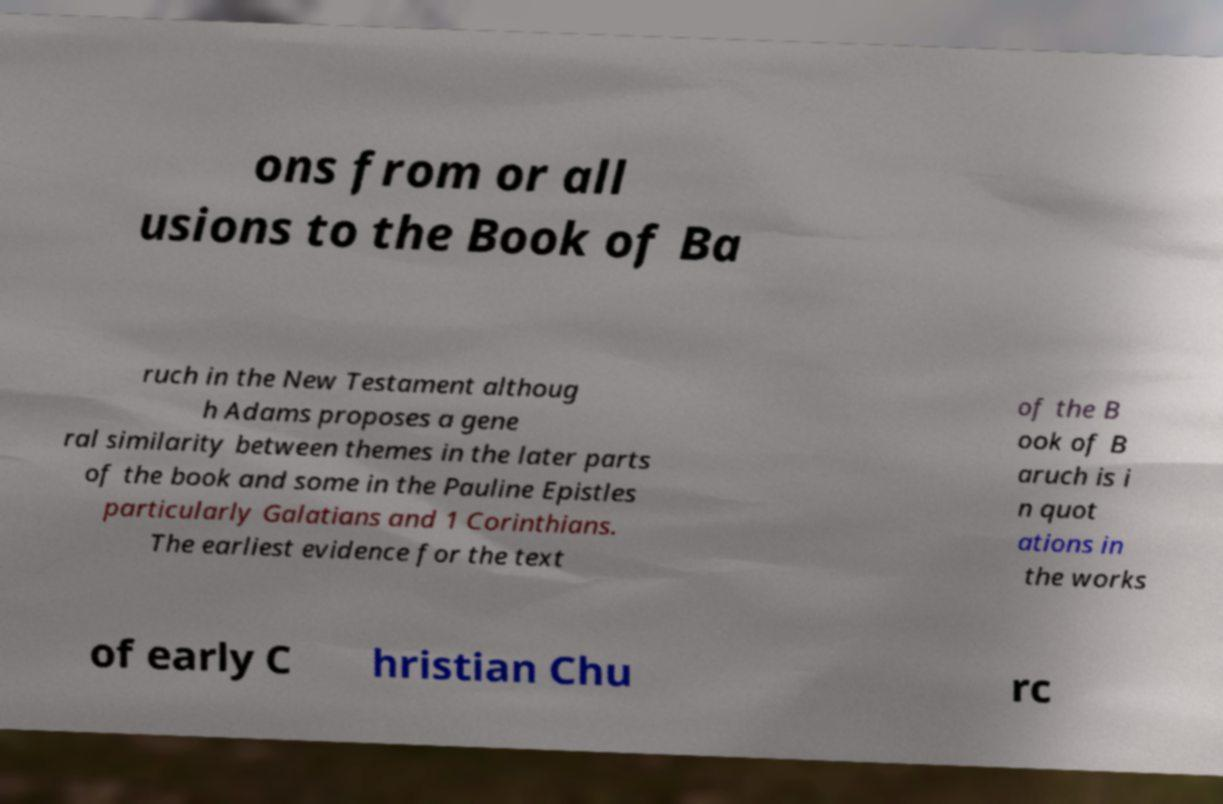There's text embedded in this image that I need extracted. Can you transcribe it verbatim? ons from or all usions to the Book of Ba ruch in the New Testament althoug h Adams proposes a gene ral similarity between themes in the later parts of the book and some in the Pauline Epistles particularly Galatians and 1 Corinthians. The earliest evidence for the text of the B ook of B aruch is i n quot ations in the works of early C hristian Chu rc 